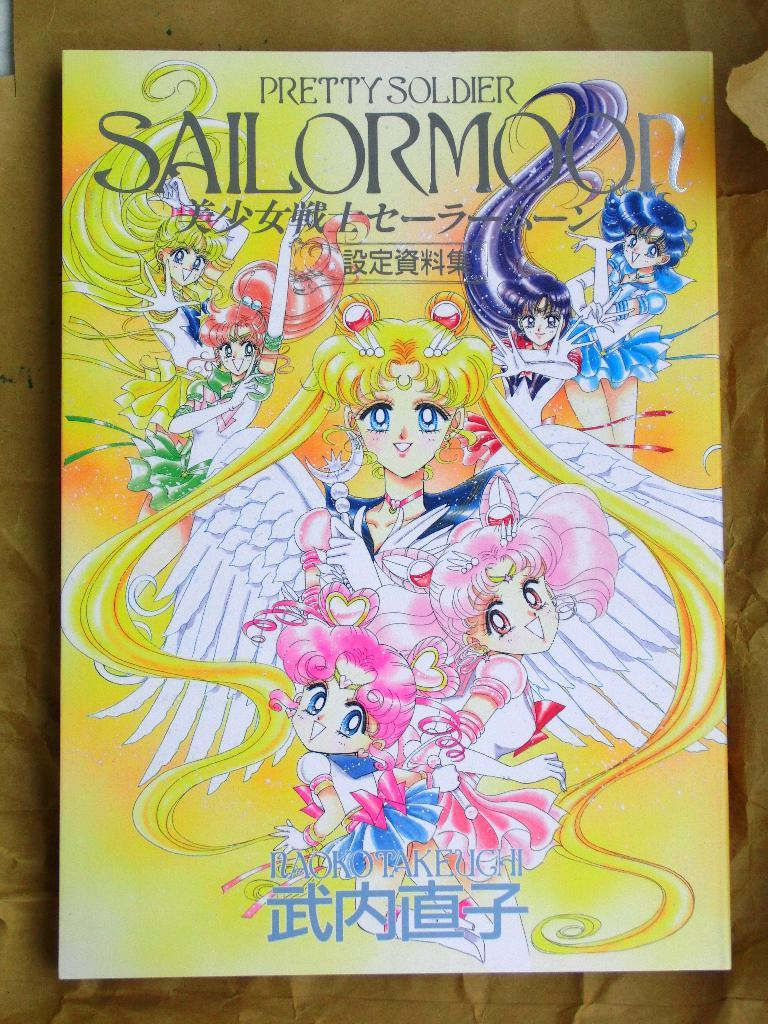<image>
Offer a succinct explanation of the picture presented. s book with the title Pretty Soldier at the top 